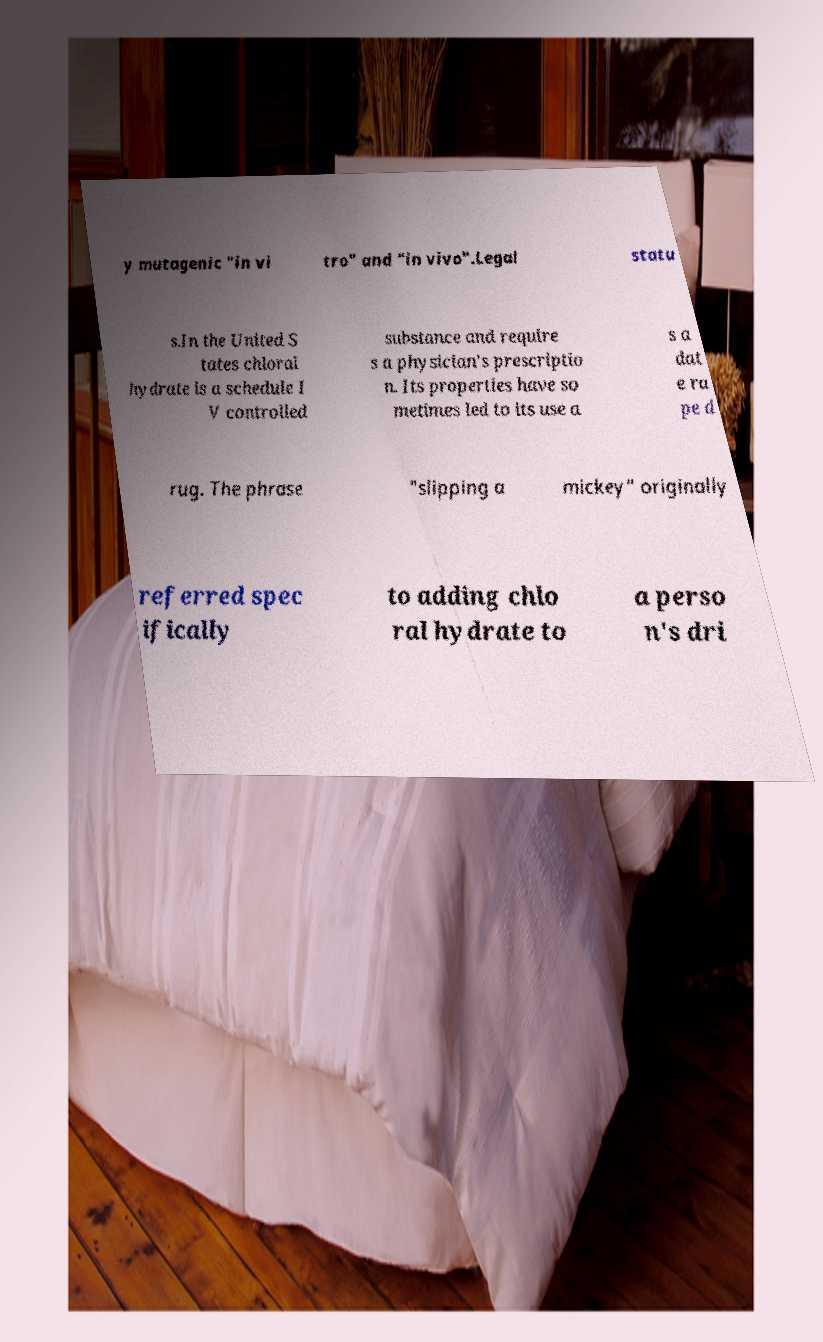Could you extract and type out the text from this image? y mutagenic "in vi tro" and "in vivo".Legal statu s.In the United S tates chloral hydrate is a schedule I V controlled substance and require s a physician's prescriptio n. Its properties have so metimes led to its use a s a dat e ra pe d rug. The phrase "slipping a mickey" originally referred spec ifically to adding chlo ral hydrate to a perso n's dri 